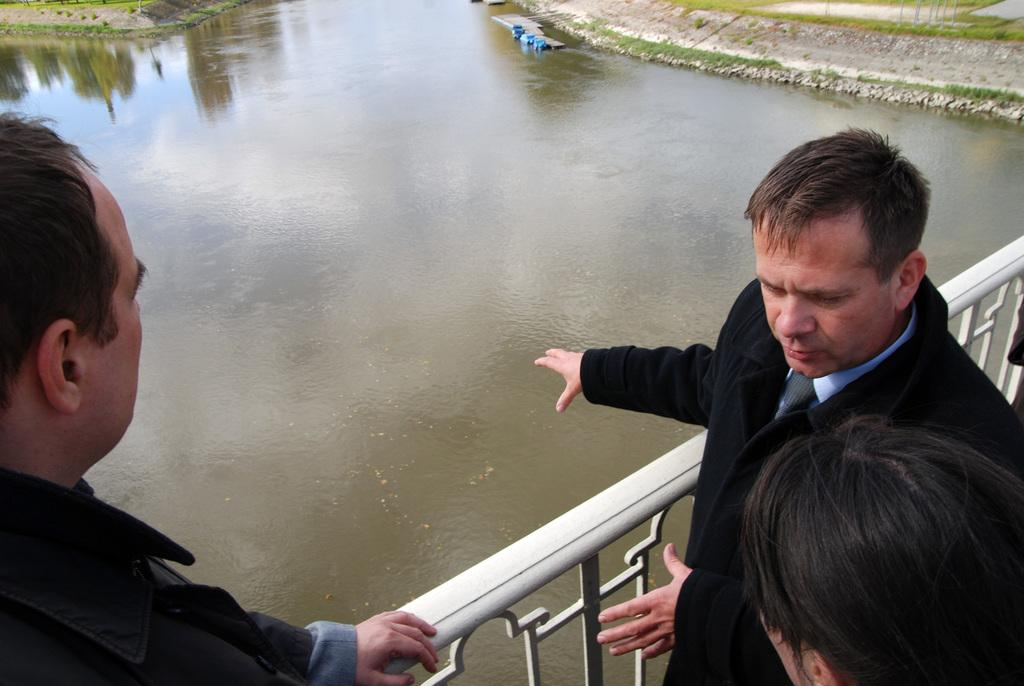What are the people in the image doing? The people in the image are standing on a bridge. What feature does the bridge have? The bridge has a railing. What can be seen in the background of the image? There is a lake and land visible in the background of the image. What color crayon is being used to draw on the brick wall in the image? There is no crayon or brick wall present in the image. 